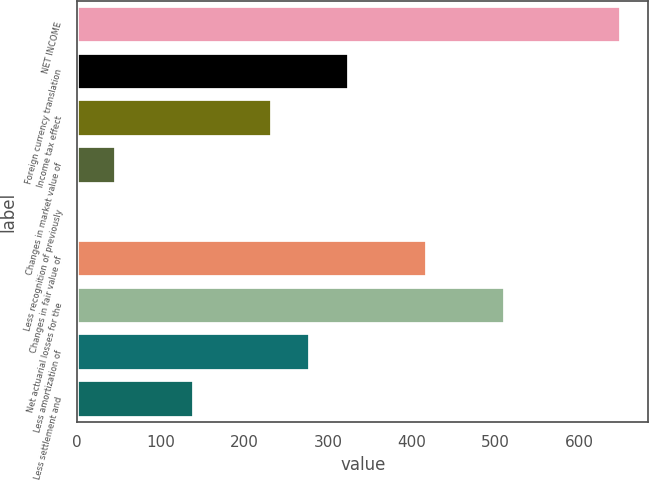<chart> <loc_0><loc_0><loc_500><loc_500><bar_chart><fcel>NET INCOME<fcel>Foreign currency translation<fcel>Income tax effect<fcel>Changes in market value of<fcel>Less recognition of previously<fcel>Changes in fair value of<fcel>Net actuarial losses for the<fcel>Less amortization of<fcel>Less settlement and<nl><fcel>650.32<fcel>325.31<fcel>232.45<fcel>46.73<fcel>0.3<fcel>418.17<fcel>511.03<fcel>278.88<fcel>139.59<nl></chart> 